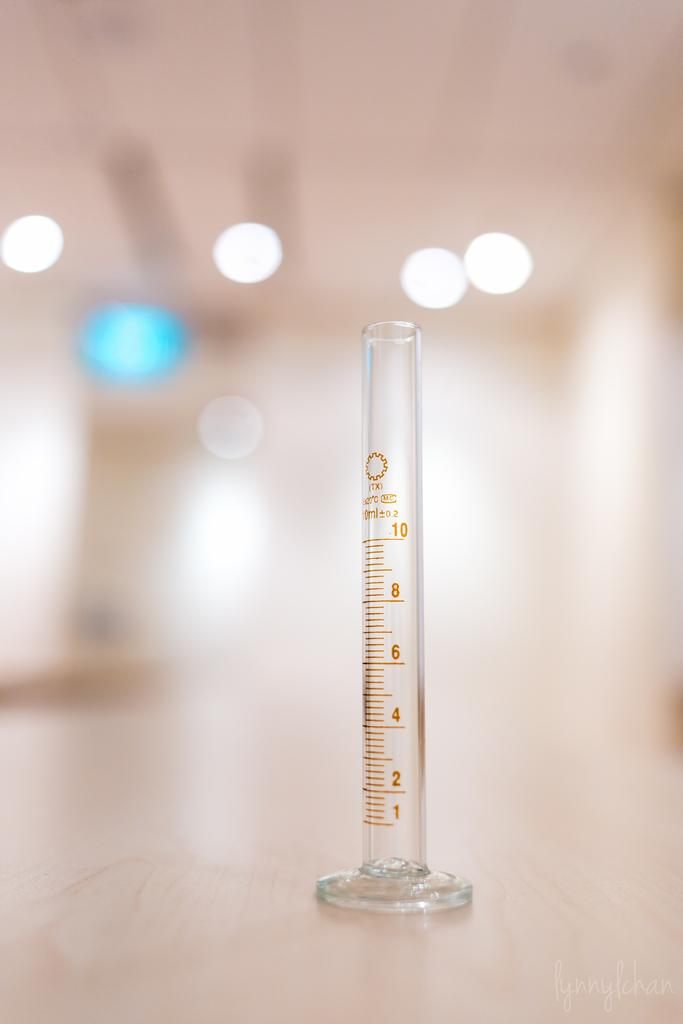Provide a one-sentence caption for the provided image. Measuring stick that go all the way up to ten. 